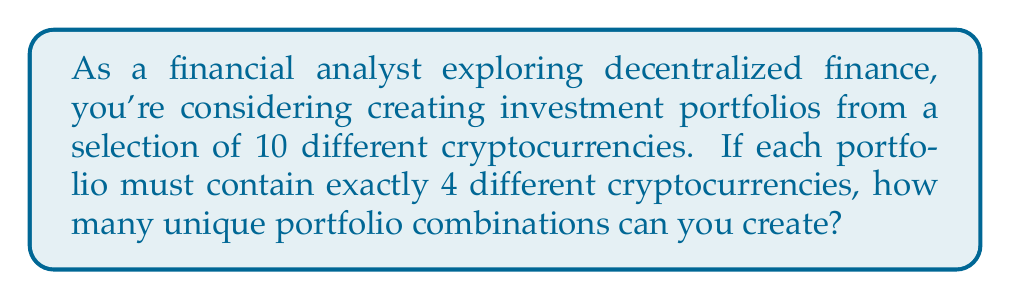Teach me how to tackle this problem. Let's approach this step-by-step:

1) This is a combination problem. We are selecting 4 cryptocurrencies out of 10, where the order doesn't matter (since it's a portfolio, not a ranking).

2) The formula for combinations is:

   $$C(n,r) = \frac{n!}{r!(n-r)!}$$

   Where $n$ is the total number of items to choose from, and $r$ is the number of items being chosen.

3) In this case, $n = 10$ (total cryptocurrencies) and $r = 4$ (cryptocurrencies in each portfolio).

4) Let's substitute these values into our formula:

   $$C(10,4) = \frac{10!}{4!(10-4)!} = \frac{10!}{4!6!}$$

5) Expand this:
   
   $$\frac{10 \times 9 \times 8 \times 7 \times 6!}{(4 \times 3 \times 2 \times 1) \times 6!}$$

6) The 6! cancels out in the numerator and denominator:

   $$\frac{10 \times 9 \times 8 \times 7}{4 \times 3 \times 2 \times 1}$$

7) Multiply the numerator and denominator:

   $$\frac{5040}{24} = 210$$

Therefore, you can create 210 unique portfolio combinations.
Answer: 210 